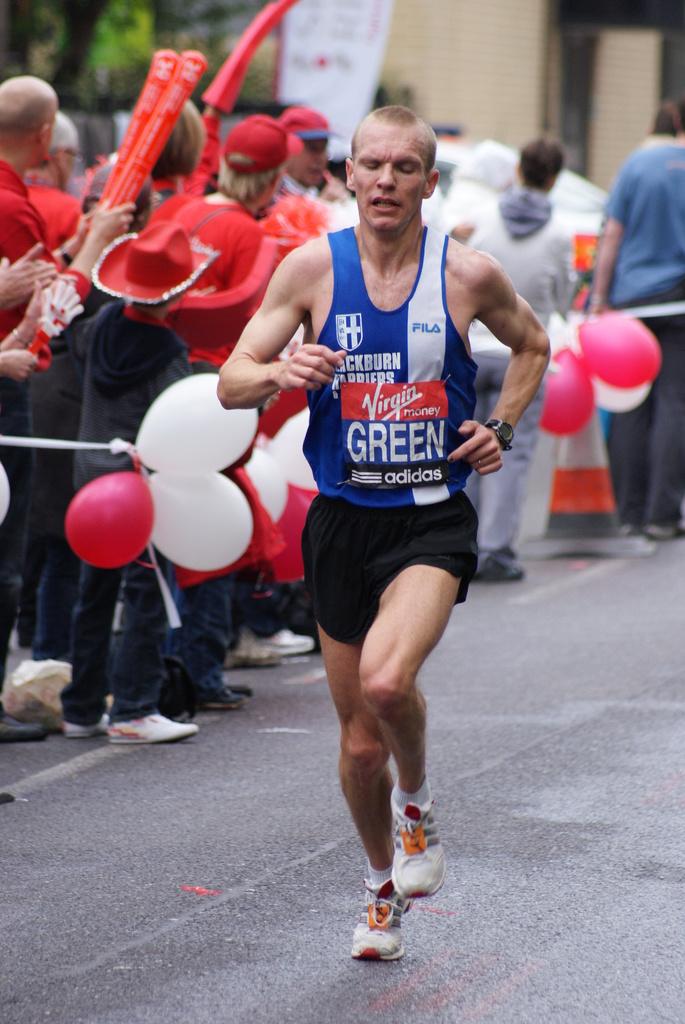Who is a sponsor of this race?
Make the answer very short. Virgin. What shoe company is advertised on the top right of the shirt?
Offer a very short reply. Fila. 